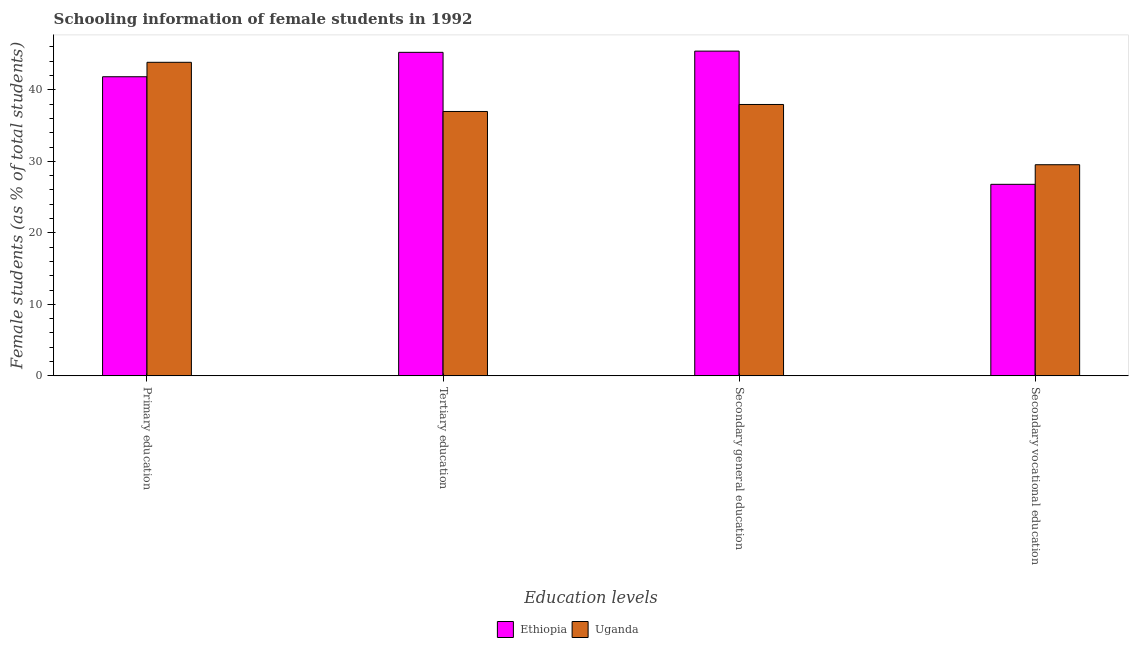Are the number of bars per tick equal to the number of legend labels?
Your answer should be compact. Yes. How many bars are there on the 1st tick from the left?
Give a very brief answer. 2. How many bars are there on the 1st tick from the right?
Provide a short and direct response. 2. What is the percentage of female students in tertiary education in Ethiopia?
Offer a very short reply. 45.24. Across all countries, what is the maximum percentage of female students in tertiary education?
Ensure brevity in your answer.  45.24. Across all countries, what is the minimum percentage of female students in primary education?
Provide a short and direct response. 41.83. In which country was the percentage of female students in secondary vocational education maximum?
Offer a terse response. Uganda. In which country was the percentage of female students in secondary vocational education minimum?
Provide a succinct answer. Ethiopia. What is the total percentage of female students in secondary vocational education in the graph?
Offer a very short reply. 56.32. What is the difference between the percentage of female students in secondary vocational education in Uganda and that in Ethiopia?
Offer a very short reply. 2.74. What is the difference between the percentage of female students in primary education in Ethiopia and the percentage of female students in tertiary education in Uganda?
Offer a terse response. 4.86. What is the average percentage of female students in secondary vocational education per country?
Keep it short and to the point. 28.16. What is the difference between the percentage of female students in secondary education and percentage of female students in secondary vocational education in Ethiopia?
Offer a very short reply. 18.63. In how many countries, is the percentage of female students in primary education greater than 20 %?
Offer a terse response. 2. What is the ratio of the percentage of female students in primary education in Ethiopia to that in Uganda?
Offer a very short reply. 0.95. Is the percentage of female students in secondary vocational education in Uganda less than that in Ethiopia?
Ensure brevity in your answer.  No. What is the difference between the highest and the second highest percentage of female students in primary education?
Your answer should be very brief. 2.02. What is the difference between the highest and the lowest percentage of female students in secondary education?
Make the answer very short. 7.46. In how many countries, is the percentage of female students in tertiary education greater than the average percentage of female students in tertiary education taken over all countries?
Keep it short and to the point. 1. Is the sum of the percentage of female students in secondary education in Ethiopia and Uganda greater than the maximum percentage of female students in secondary vocational education across all countries?
Provide a short and direct response. Yes. Is it the case that in every country, the sum of the percentage of female students in primary education and percentage of female students in tertiary education is greater than the sum of percentage of female students in secondary education and percentage of female students in secondary vocational education?
Offer a very short reply. No. What does the 1st bar from the left in Secondary vocational education represents?
Keep it short and to the point. Ethiopia. What does the 1st bar from the right in Secondary general education represents?
Ensure brevity in your answer.  Uganda. Are the values on the major ticks of Y-axis written in scientific E-notation?
Provide a succinct answer. No. Does the graph contain grids?
Ensure brevity in your answer.  No. Where does the legend appear in the graph?
Your answer should be compact. Bottom center. What is the title of the graph?
Give a very brief answer. Schooling information of female students in 1992. Does "Cameroon" appear as one of the legend labels in the graph?
Offer a very short reply. No. What is the label or title of the X-axis?
Your answer should be compact. Education levels. What is the label or title of the Y-axis?
Offer a terse response. Female students (as % of total students). What is the Female students (as % of total students) in Ethiopia in Primary education?
Provide a succinct answer. 41.83. What is the Female students (as % of total students) of Uganda in Primary education?
Provide a short and direct response. 43.85. What is the Female students (as % of total students) of Ethiopia in Tertiary education?
Your answer should be very brief. 45.24. What is the Female students (as % of total students) of Uganda in Tertiary education?
Provide a short and direct response. 36.97. What is the Female students (as % of total students) in Ethiopia in Secondary general education?
Make the answer very short. 45.42. What is the Female students (as % of total students) of Uganda in Secondary general education?
Provide a succinct answer. 37.95. What is the Female students (as % of total students) in Ethiopia in Secondary vocational education?
Ensure brevity in your answer.  26.79. What is the Female students (as % of total students) in Uganda in Secondary vocational education?
Offer a terse response. 29.53. Across all Education levels, what is the maximum Female students (as % of total students) of Ethiopia?
Give a very brief answer. 45.42. Across all Education levels, what is the maximum Female students (as % of total students) in Uganda?
Your answer should be compact. 43.85. Across all Education levels, what is the minimum Female students (as % of total students) in Ethiopia?
Offer a very short reply. 26.79. Across all Education levels, what is the minimum Female students (as % of total students) of Uganda?
Make the answer very short. 29.53. What is the total Female students (as % of total students) in Ethiopia in the graph?
Your answer should be very brief. 159.28. What is the total Female students (as % of total students) in Uganda in the graph?
Offer a terse response. 148.3. What is the difference between the Female students (as % of total students) of Ethiopia in Primary education and that in Tertiary education?
Keep it short and to the point. -3.41. What is the difference between the Female students (as % of total students) of Uganda in Primary education and that in Tertiary education?
Give a very brief answer. 6.88. What is the difference between the Female students (as % of total students) in Ethiopia in Primary education and that in Secondary general education?
Provide a short and direct response. -3.58. What is the difference between the Female students (as % of total students) of Uganda in Primary education and that in Secondary general education?
Your response must be concise. 5.9. What is the difference between the Female students (as % of total students) of Ethiopia in Primary education and that in Secondary vocational education?
Ensure brevity in your answer.  15.04. What is the difference between the Female students (as % of total students) in Uganda in Primary education and that in Secondary vocational education?
Your answer should be compact. 14.32. What is the difference between the Female students (as % of total students) in Ethiopia in Tertiary education and that in Secondary general education?
Your response must be concise. -0.17. What is the difference between the Female students (as % of total students) of Uganda in Tertiary education and that in Secondary general education?
Offer a terse response. -0.98. What is the difference between the Female students (as % of total students) of Ethiopia in Tertiary education and that in Secondary vocational education?
Give a very brief answer. 18.46. What is the difference between the Female students (as % of total students) in Uganda in Tertiary education and that in Secondary vocational education?
Make the answer very short. 7.45. What is the difference between the Female students (as % of total students) of Ethiopia in Secondary general education and that in Secondary vocational education?
Give a very brief answer. 18.63. What is the difference between the Female students (as % of total students) of Uganda in Secondary general education and that in Secondary vocational education?
Offer a very short reply. 8.43. What is the difference between the Female students (as % of total students) in Ethiopia in Primary education and the Female students (as % of total students) in Uganda in Tertiary education?
Provide a succinct answer. 4.86. What is the difference between the Female students (as % of total students) in Ethiopia in Primary education and the Female students (as % of total students) in Uganda in Secondary general education?
Your response must be concise. 3.88. What is the difference between the Female students (as % of total students) of Ethiopia in Primary education and the Female students (as % of total students) of Uganda in Secondary vocational education?
Offer a terse response. 12.3. What is the difference between the Female students (as % of total students) in Ethiopia in Tertiary education and the Female students (as % of total students) in Uganda in Secondary general education?
Offer a terse response. 7.29. What is the difference between the Female students (as % of total students) in Ethiopia in Tertiary education and the Female students (as % of total students) in Uganda in Secondary vocational education?
Make the answer very short. 15.72. What is the difference between the Female students (as % of total students) of Ethiopia in Secondary general education and the Female students (as % of total students) of Uganda in Secondary vocational education?
Your answer should be very brief. 15.89. What is the average Female students (as % of total students) of Ethiopia per Education levels?
Provide a short and direct response. 39.82. What is the average Female students (as % of total students) in Uganda per Education levels?
Provide a short and direct response. 37.08. What is the difference between the Female students (as % of total students) in Ethiopia and Female students (as % of total students) in Uganda in Primary education?
Give a very brief answer. -2.02. What is the difference between the Female students (as % of total students) of Ethiopia and Female students (as % of total students) of Uganda in Tertiary education?
Offer a very short reply. 8.27. What is the difference between the Female students (as % of total students) in Ethiopia and Female students (as % of total students) in Uganda in Secondary general education?
Give a very brief answer. 7.46. What is the difference between the Female students (as % of total students) in Ethiopia and Female students (as % of total students) in Uganda in Secondary vocational education?
Keep it short and to the point. -2.74. What is the ratio of the Female students (as % of total students) in Ethiopia in Primary education to that in Tertiary education?
Offer a terse response. 0.92. What is the ratio of the Female students (as % of total students) in Uganda in Primary education to that in Tertiary education?
Provide a succinct answer. 1.19. What is the ratio of the Female students (as % of total students) in Ethiopia in Primary education to that in Secondary general education?
Keep it short and to the point. 0.92. What is the ratio of the Female students (as % of total students) of Uganda in Primary education to that in Secondary general education?
Make the answer very short. 1.16. What is the ratio of the Female students (as % of total students) in Ethiopia in Primary education to that in Secondary vocational education?
Offer a terse response. 1.56. What is the ratio of the Female students (as % of total students) in Uganda in Primary education to that in Secondary vocational education?
Keep it short and to the point. 1.49. What is the ratio of the Female students (as % of total students) of Ethiopia in Tertiary education to that in Secondary general education?
Keep it short and to the point. 1. What is the ratio of the Female students (as % of total students) in Uganda in Tertiary education to that in Secondary general education?
Your response must be concise. 0.97. What is the ratio of the Female students (as % of total students) in Ethiopia in Tertiary education to that in Secondary vocational education?
Give a very brief answer. 1.69. What is the ratio of the Female students (as % of total students) in Uganda in Tertiary education to that in Secondary vocational education?
Offer a terse response. 1.25. What is the ratio of the Female students (as % of total students) of Ethiopia in Secondary general education to that in Secondary vocational education?
Your response must be concise. 1.7. What is the ratio of the Female students (as % of total students) of Uganda in Secondary general education to that in Secondary vocational education?
Provide a succinct answer. 1.29. What is the difference between the highest and the second highest Female students (as % of total students) in Ethiopia?
Your response must be concise. 0.17. What is the difference between the highest and the second highest Female students (as % of total students) of Uganda?
Ensure brevity in your answer.  5.9. What is the difference between the highest and the lowest Female students (as % of total students) in Ethiopia?
Provide a short and direct response. 18.63. What is the difference between the highest and the lowest Female students (as % of total students) in Uganda?
Your answer should be very brief. 14.32. 